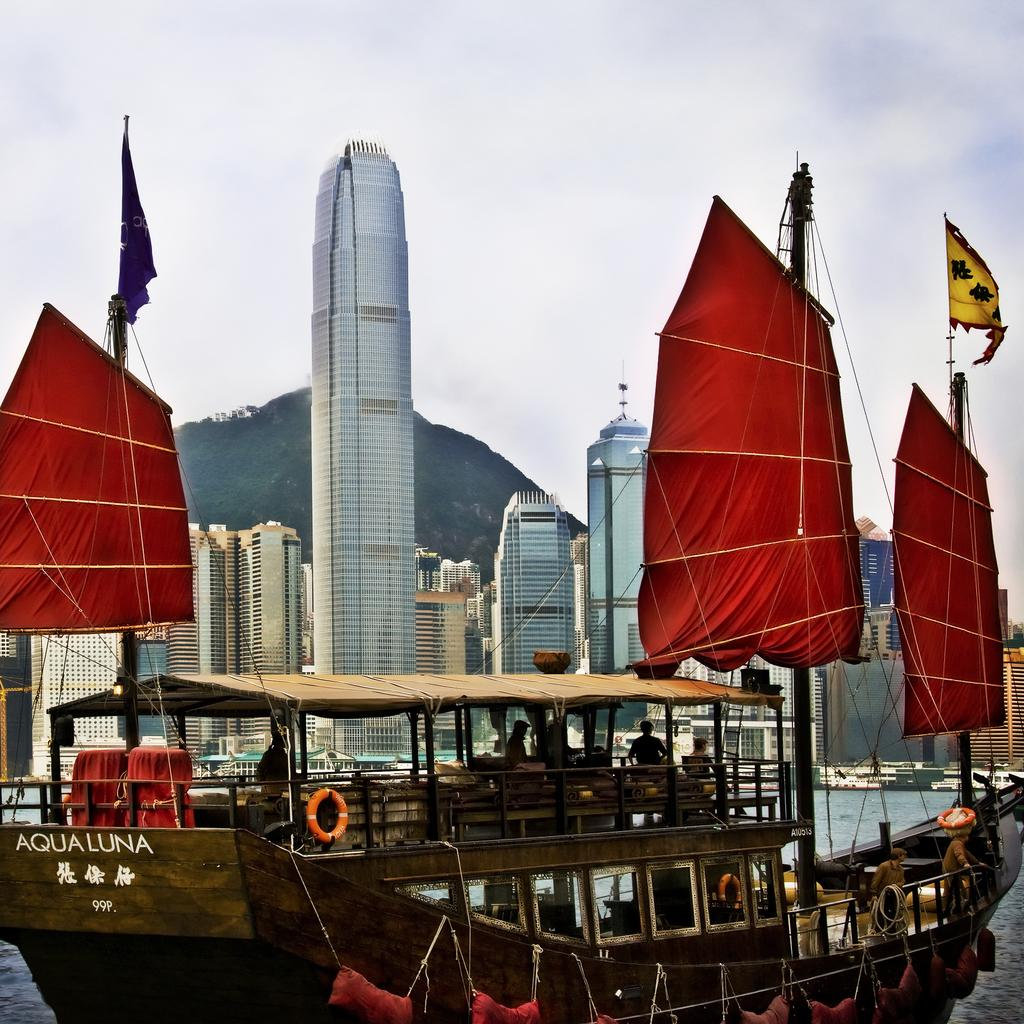What is the main subject of the image? The main subject of the image is a ship above the water. Are there any people on the ship? Yes, there are people in the ship. What features can be seen on the ship? The ship has a sail, flags, ropes, and tubes. What can be seen in the background of the image? Buildings and the sky are visible in the background of the image. What type of branch can be seen holding a ball in the image? There is no branch or ball present in the image; it features a ship with various features and a background with buildings and the sky. 